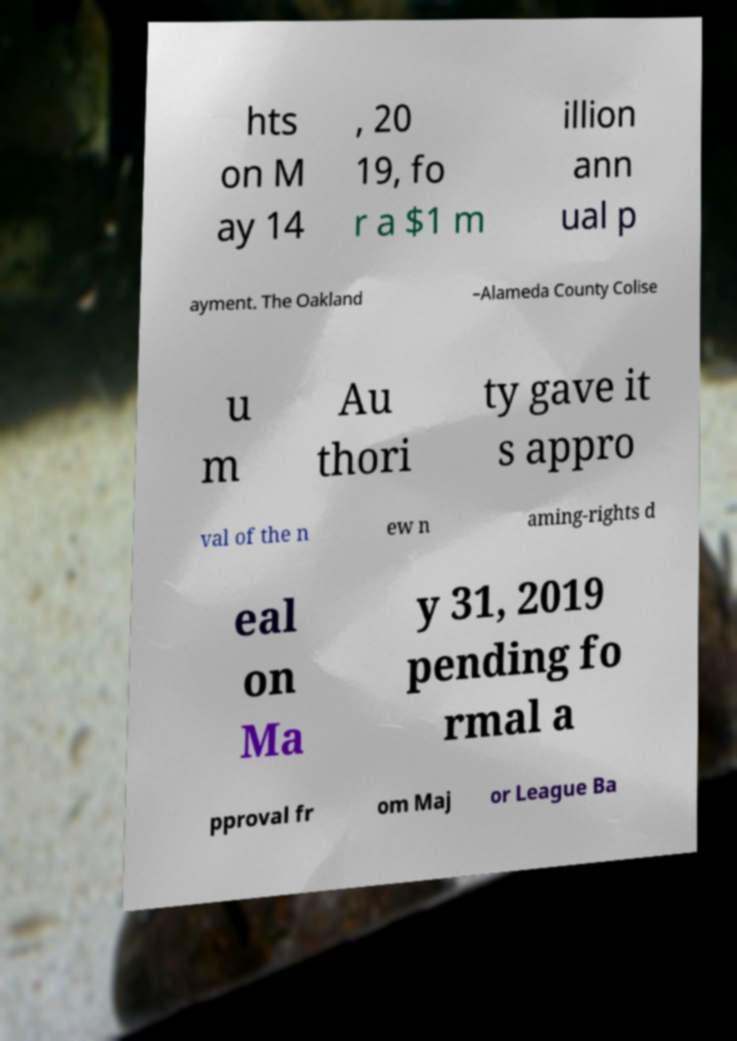What messages or text are displayed in this image? I need them in a readable, typed format. hts on M ay 14 , 20 19, fo r a $1 m illion ann ual p ayment. The Oakland –Alameda County Colise u m Au thori ty gave it s appro val of the n ew n aming-rights d eal on Ma y 31, 2019 pending fo rmal a pproval fr om Maj or League Ba 